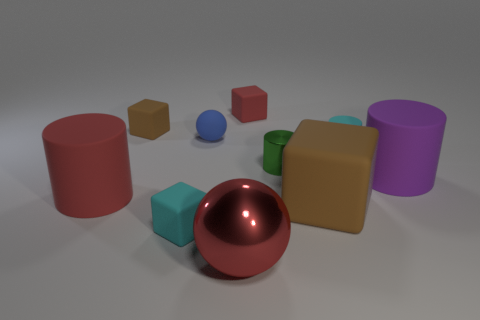Subtract 1 cylinders. How many cylinders are left? 3 Subtract all cylinders. How many objects are left? 6 Add 8 small brown things. How many small brown things exist? 9 Subtract 0 purple spheres. How many objects are left? 10 Subtract all purple cylinders. Subtract all small red things. How many objects are left? 8 Add 3 metallic spheres. How many metallic spheres are left? 4 